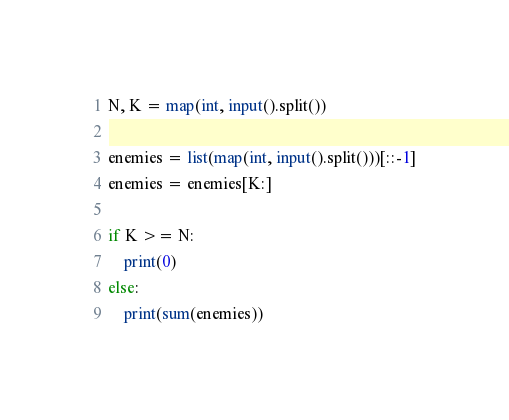<code> <loc_0><loc_0><loc_500><loc_500><_Python_>N, K = map(int, input().split())

enemies = list(map(int, input().split()))[::-1]
enemies = enemies[K:]

if K >= N:
    print(0)
else:
    print(sum(enemies))</code> 